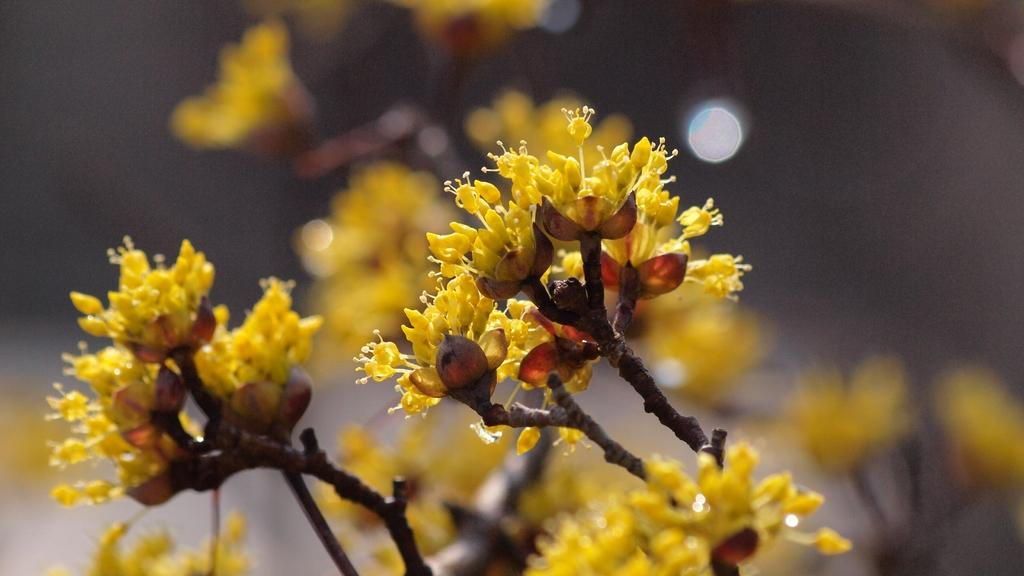What type of plant is in the image? There is a yellow flower plant in the image. Where is the plant located in relation to the image? The flower plant is in the front of the image. What can be observed about the background of the image? The background of the image is blurred. What type of lead can be seen in the image? There is no lead present in the image; it features a yellow flower plant in the front with a blurred background. 